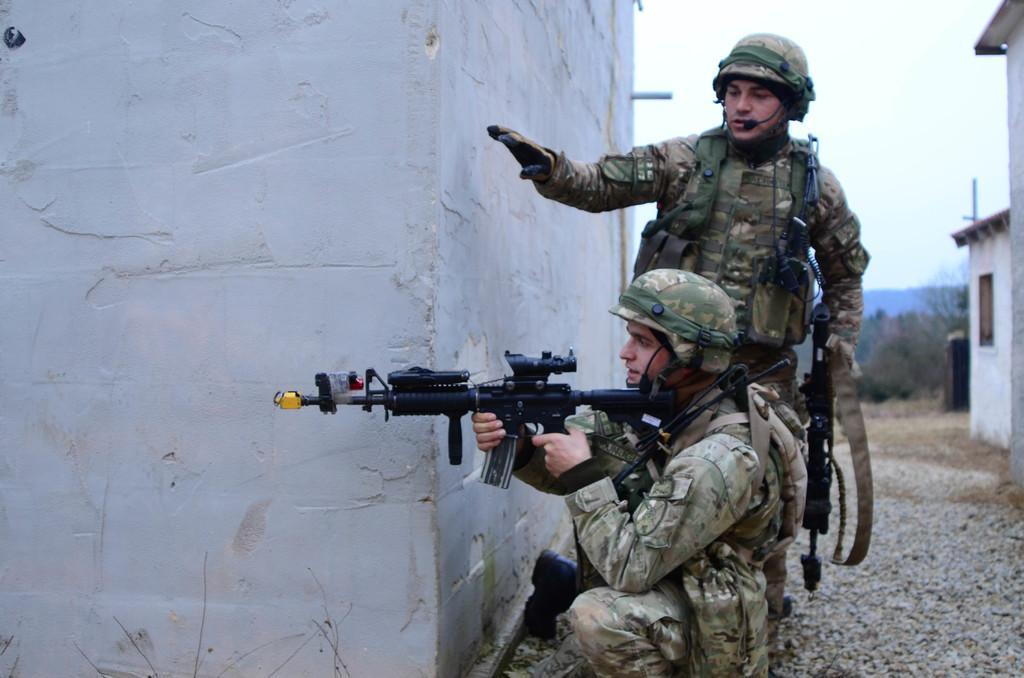How would you summarize this image in a sentence or two? The man in the uniform is holding a rifle in his hand. Beside him, the man in the uniform is holding a rifle in his hand and he is standing. Beside them, we see a white wall. At the bottom of the picture, we see concrete stones. On the right side, we see buildings in white color. There are trees and hills in the background. In the right top of the picture, we see the sky. 